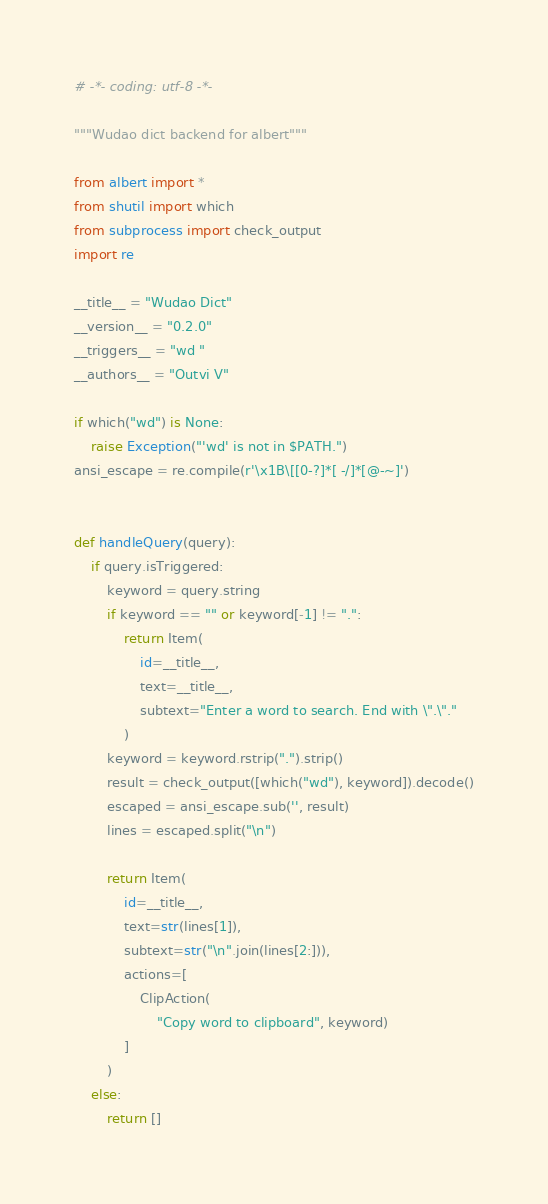<code> <loc_0><loc_0><loc_500><loc_500><_Python_># -*- coding: utf-8 -*-

"""Wudao dict backend for albert"""

from albert import *
from shutil import which
from subprocess import check_output
import re

__title__ = "Wudao Dict"
__version__ = "0.2.0"
__triggers__ = "wd "
__authors__ = "Outvi V"

if which("wd") is None:
    raise Exception("'wd' is not in $PATH.")
ansi_escape = re.compile(r'\x1B\[[0-?]*[ -/]*[@-~]')


def handleQuery(query):
    if query.isTriggered:
        keyword = query.string
        if keyword == "" or keyword[-1] != ".":
            return Item(
                id=__title__,
                text=__title__,
                subtext="Enter a word to search. End with \".\"."
            )
        keyword = keyword.rstrip(".").strip()
        result = check_output([which("wd"), keyword]).decode()
        escaped = ansi_escape.sub('', result)
        lines = escaped.split("\n")

        return Item(
            id=__title__,
            text=str(lines[1]),
            subtext=str("\n".join(lines[2:])),
            actions=[
                ClipAction(
                    "Copy word to clipboard", keyword)
            ]
        )
    else:
        return []
</code> 